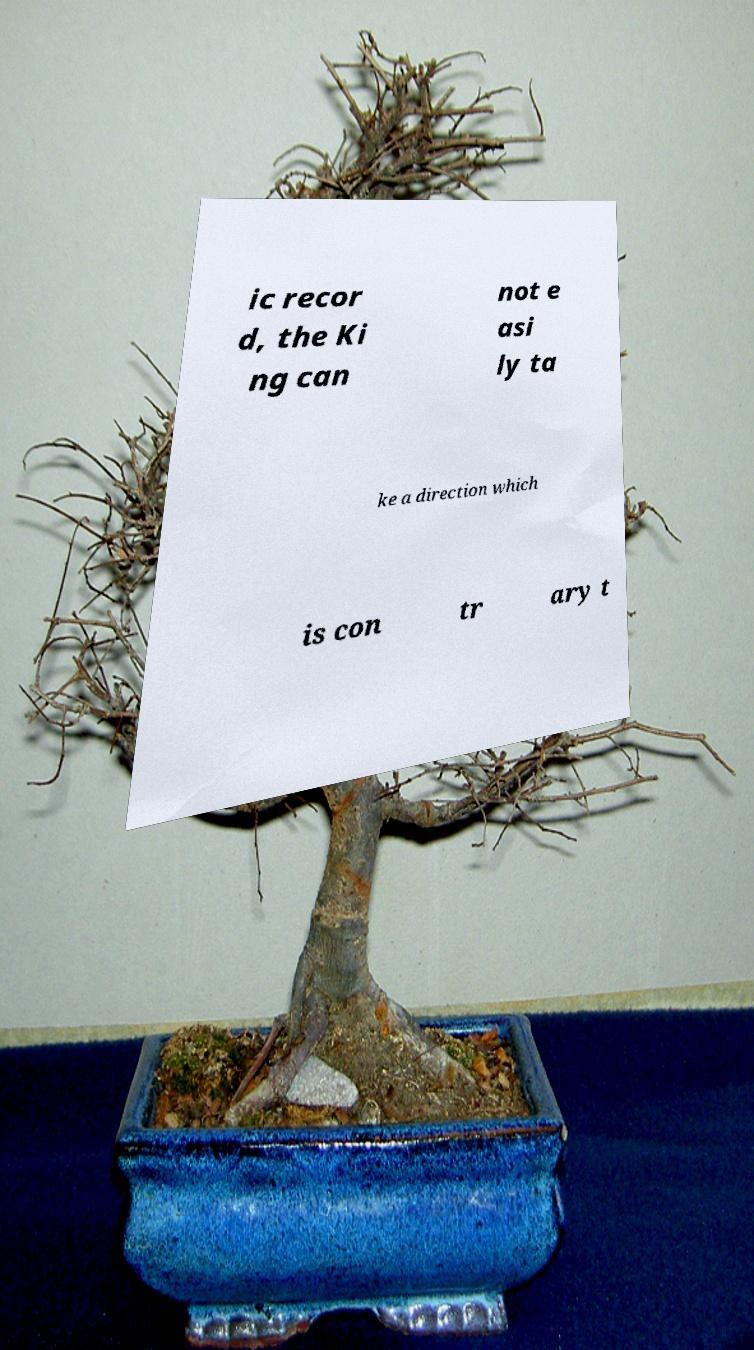Please identify and transcribe the text found in this image. ic recor d, the Ki ng can not e asi ly ta ke a direction which is con tr ary t 